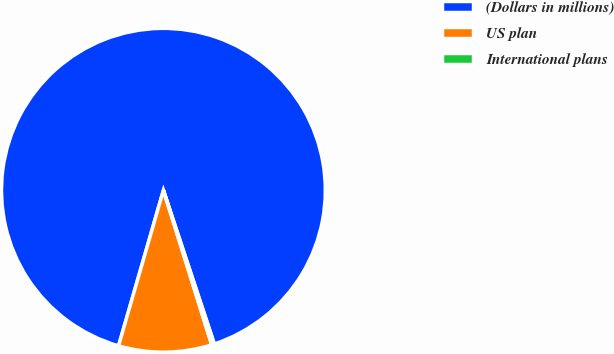Convert chart to OTSL. <chart><loc_0><loc_0><loc_500><loc_500><pie_chart><fcel>(Dollars in millions)<fcel>US plan<fcel>International plans<nl><fcel>90.44%<fcel>9.29%<fcel>0.27%<nl></chart> 